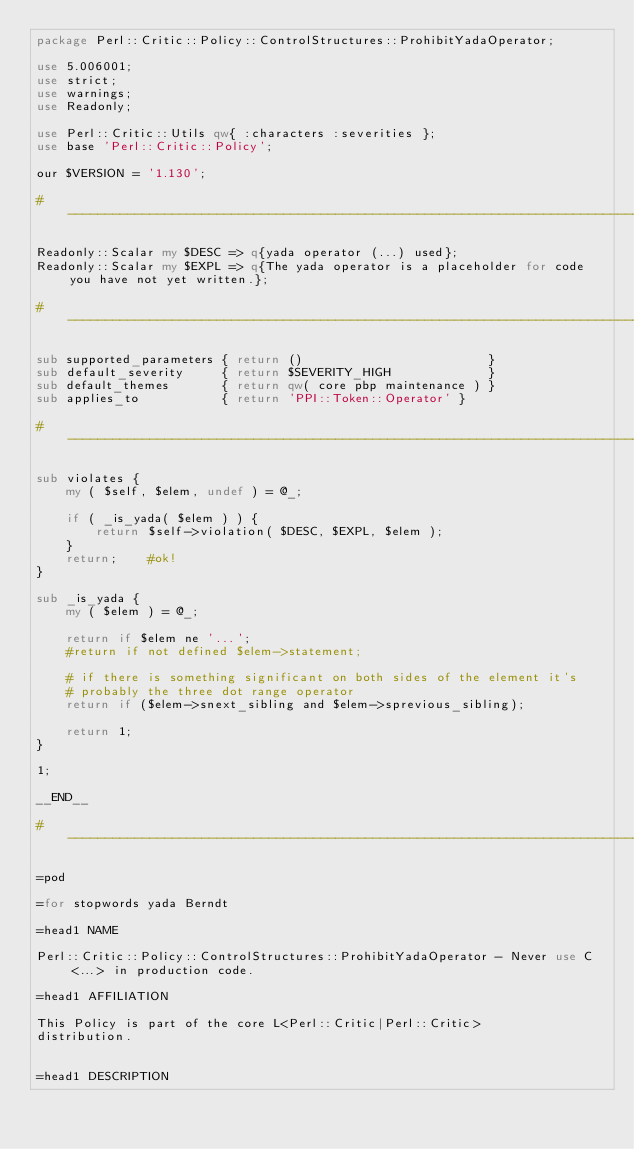Convert code to text. <code><loc_0><loc_0><loc_500><loc_500><_Perl_>package Perl::Critic::Policy::ControlStructures::ProhibitYadaOperator;

use 5.006001;
use strict;
use warnings;
use Readonly;

use Perl::Critic::Utils qw{ :characters :severities };
use base 'Perl::Critic::Policy';

our $VERSION = '1.130';

#-----------------------------------------------------------------------------

Readonly::Scalar my $DESC => q{yada operator (...) used};
Readonly::Scalar my $EXPL => q{The yada operator is a placeholder for code you have not yet written.};

#-----------------------------------------------------------------------------

sub supported_parameters { return ()                         }
sub default_severity     { return $SEVERITY_HIGH             }
sub default_themes       { return qw( core pbp maintenance ) }
sub applies_to           { return 'PPI::Token::Operator' }

#-----------------------------------------------------------------------------

sub violates {
    my ( $self, $elem, undef ) = @_;

    if ( _is_yada( $elem ) ) {
        return $self->violation( $DESC, $EXPL, $elem );
    }
    return;    #ok!
}

sub _is_yada {
    my ( $elem ) = @_;

    return if $elem ne '...';
    #return if not defined $elem->statement;

    # if there is something significant on both sides of the element it's
    # probably the three dot range operator
    return if ($elem->snext_sibling and $elem->sprevious_sibling);

    return 1;
}

1;

__END__

#-----------------------------------------------------------------------------

=pod

=for stopwords yada Berndt

=head1 NAME

Perl::Critic::Policy::ControlStructures::ProhibitYadaOperator - Never use C<...> in production code.

=head1 AFFILIATION

This Policy is part of the core L<Perl::Critic|Perl::Critic>
distribution.


=head1 DESCRIPTION
</code> 